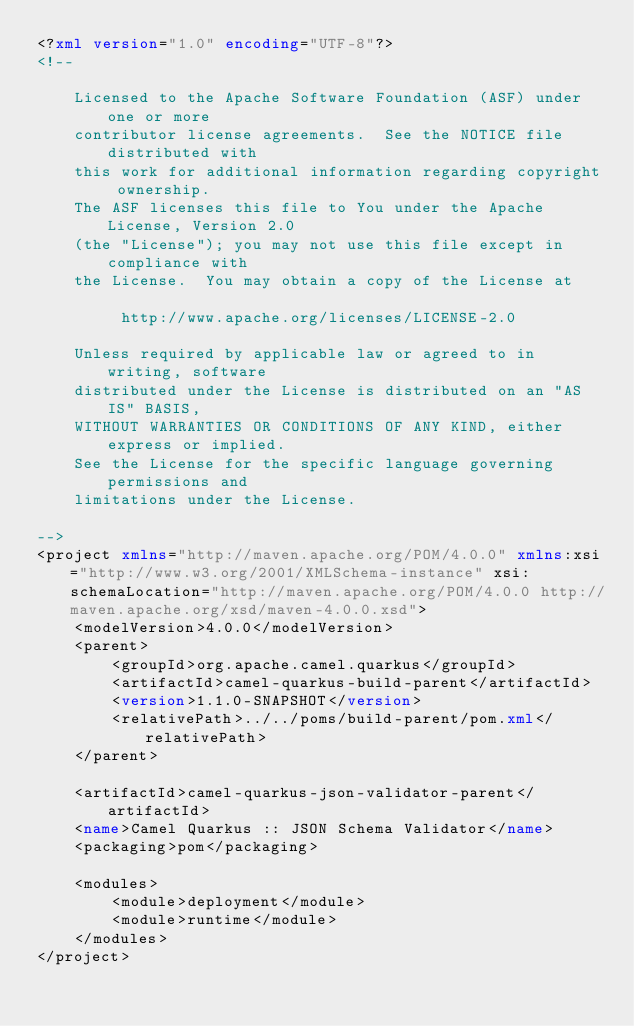Convert code to text. <code><loc_0><loc_0><loc_500><loc_500><_XML_><?xml version="1.0" encoding="UTF-8"?>
<!--

    Licensed to the Apache Software Foundation (ASF) under one or more
    contributor license agreements.  See the NOTICE file distributed with
    this work for additional information regarding copyright ownership.
    The ASF licenses this file to You under the Apache License, Version 2.0
    (the "License"); you may not use this file except in compliance with
    the License.  You may obtain a copy of the License at

         http://www.apache.org/licenses/LICENSE-2.0

    Unless required by applicable law or agreed to in writing, software
    distributed under the License is distributed on an "AS IS" BASIS,
    WITHOUT WARRANTIES OR CONDITIONS OF ANY KIND, either express or implied.
    See the License for the specific language governing permissions and
    limitations under the License.

-->
<project xmlns="http://maven.apache.org/POM/4.0.0" xmlns:xsi="http://www.w3.org/2001/XMLSchema-instance" xsi:schemaLocation="http://maven.apache.org/POM/4.0.0 http://maven.apache.org/xsd/maven-4.0.0.xsd">
    <modelVersion>4.0.0</modelVersion>
    <parent>
        <groupId>org.apache.camel.quarkus</groupId>
        <artifactId>camel-quarkus-build-parent</artifactId>
        <version>1.1.0-SNAPSHOT</version>
        <relativePath>../../poms/build-parent/pom.xml</relativePath>
    </parent>

    <artifactId>camel-quarkus-json-validator-parent</artifactId>
    <name>Camel Quarkus :: JSON Schema Validator</name>
    <packaging>pom</packaging>

    <modules>
        <module>deployment</module>
        <module>runtime</module>
    </modules>
</project>
</code> 